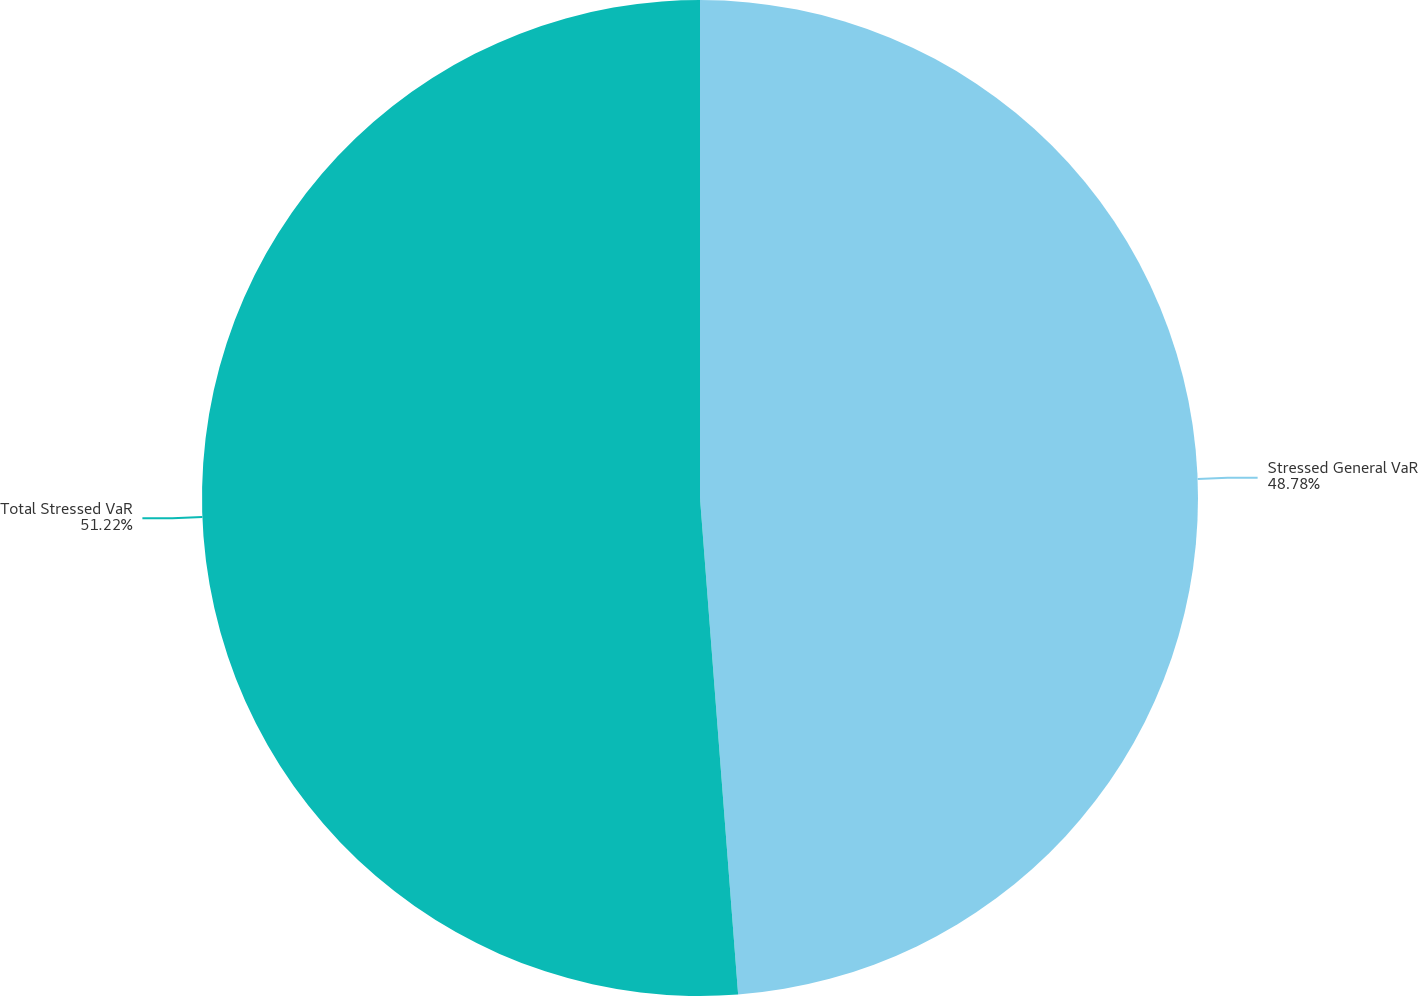Convert chart. <chart><loc_0><loc_0><loc_500><loc_500><pie_chart><fcel>Stressed General VaR<fcel>Total Stressed VaR<nl><fcel>48.78%<fcel>51.22%<nl></chart> 